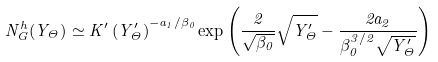<formula> <loc_0><loc_0><loc_500><loc_500>N _ { G } ^ { h } ( Y _ { \Theta } ) \simeq K ^ { \prime } \left ( Y ^ { \prime } _ { \Theta } \right ) ^ { - a _ { 1 } / \beta _ { 0 } } \exp { \left ( \frac { 2 } { \sqrt { \beta _ { 0 } } } \sqrt { Y ^ { \prime } _ { \Theta } } - \frac { 2 a _ { 2 } } { \beta _ { 0 } ^ { 3 / 2 } \sqrt { Y ^ { \prime } _ { \Theta } } } \right ) }</formula> 